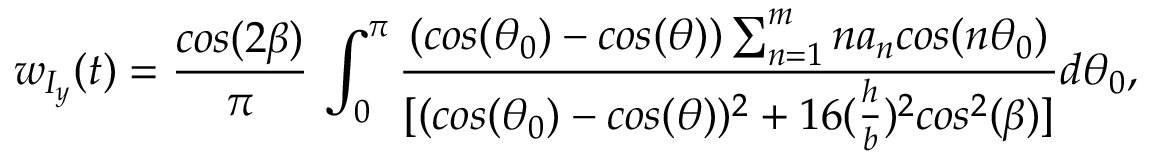<formula> <loc_0><loc_0><loc_500><loc_500>w _ { I _ { y } } ( t ) = \frac { \cos ( 2 \beta ) } { \pi } \, \int _ { 0 } ^ { \pi } \frac { ( \cos ( \theta _ { 0 } ) - \cos ( \theta ) ) \sum _ { n = 1 } ^ { m } n a _ { n } \cos ( n \theta _ { 0 } ) } { [ ( \cos ( \theta _ { 0 } ) - \cos ( \theta ) ) ^ { 2 } + 1 6 ( \frac { h } { b } ) ^ { 2 } \cos ^ { 2 } ( \beta ) ] } { d \theta _ { 0 } } ,</formula> 